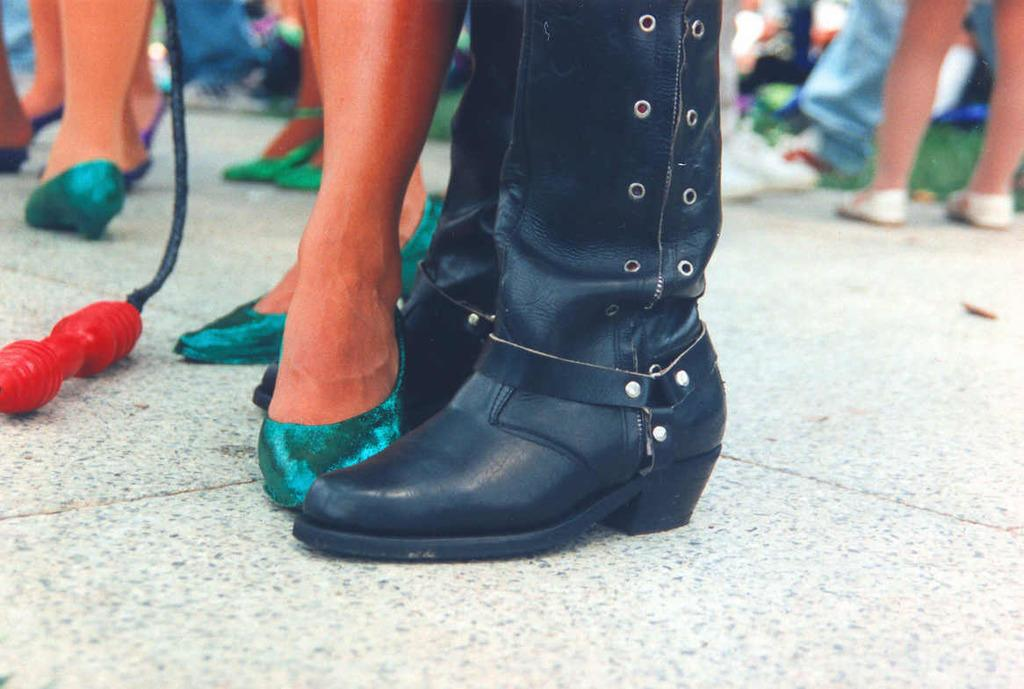What can be seen at the bottom of the image? There are legs of people visible in the image. What are the people wearing on their feet? The people are wearing footwear. Can you describe the object in the image? Unfortunately, there is not enough information provided to describe the object in the image. What type of lace can be seen on the shoes in the image? There is no information provided about the type of lace on the shoes in the image. What kind of earth is visible in the image? There is no earth visible in the image; it appears to be an indoor setting. 